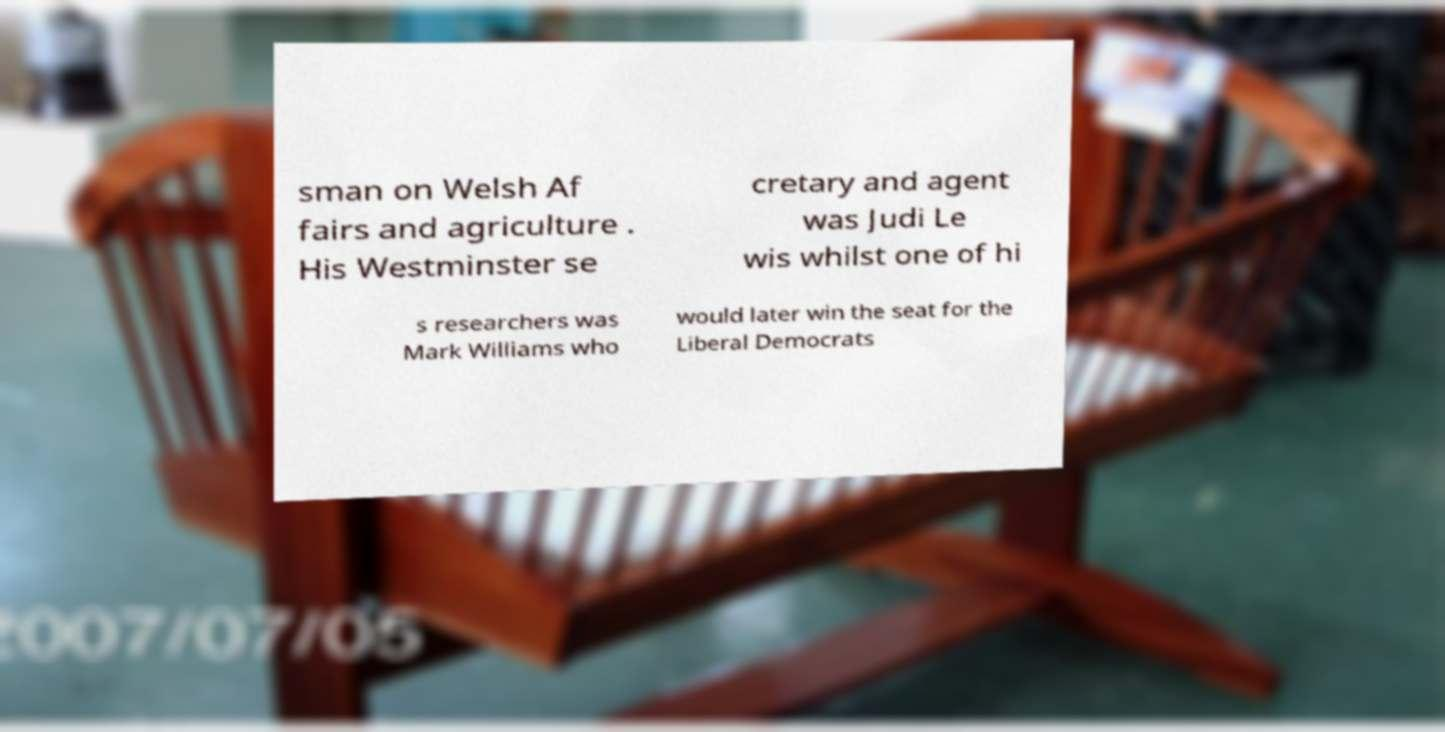There's text embedded in this image that I need extracted. Can you transcribe it verbatim? sman on Welsh Af fairs and agriculture . His Westminster se cretary and agent was Judi Le wis whilst one of hi s researchers was Mark Williams who would later win the seat for the Liberal Democrats 